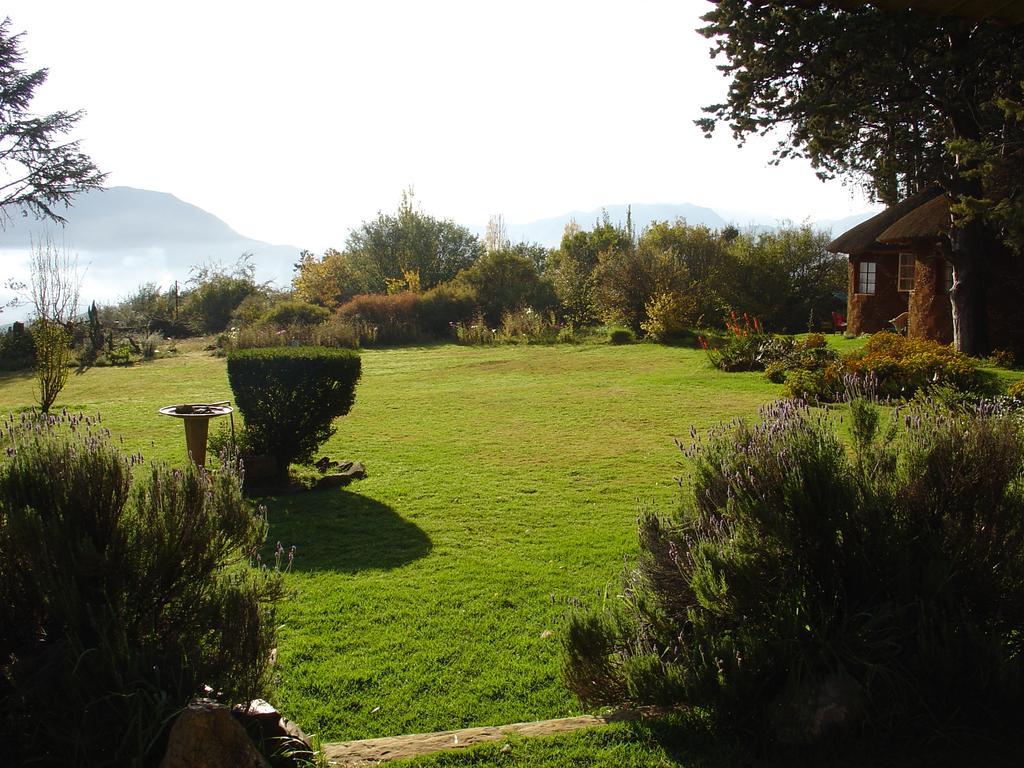How would you summarize this image in a sentence or two? In this image there is the sky towards the top of the image, there are mountains, there are trees, there is a house towards the right of the image, there is a grass, there is an object on the grass, there are plants. 